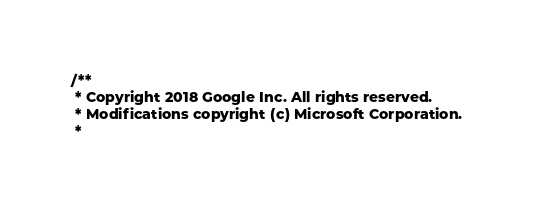<code> <loc_0><loc_0><loc_500><loc_500><_JavaScript_>/**
 * Copyright 2018 Google Inc. All rights reserved.
 * Modifications copyright (c) Microsoft Corporation.
 *</code> 